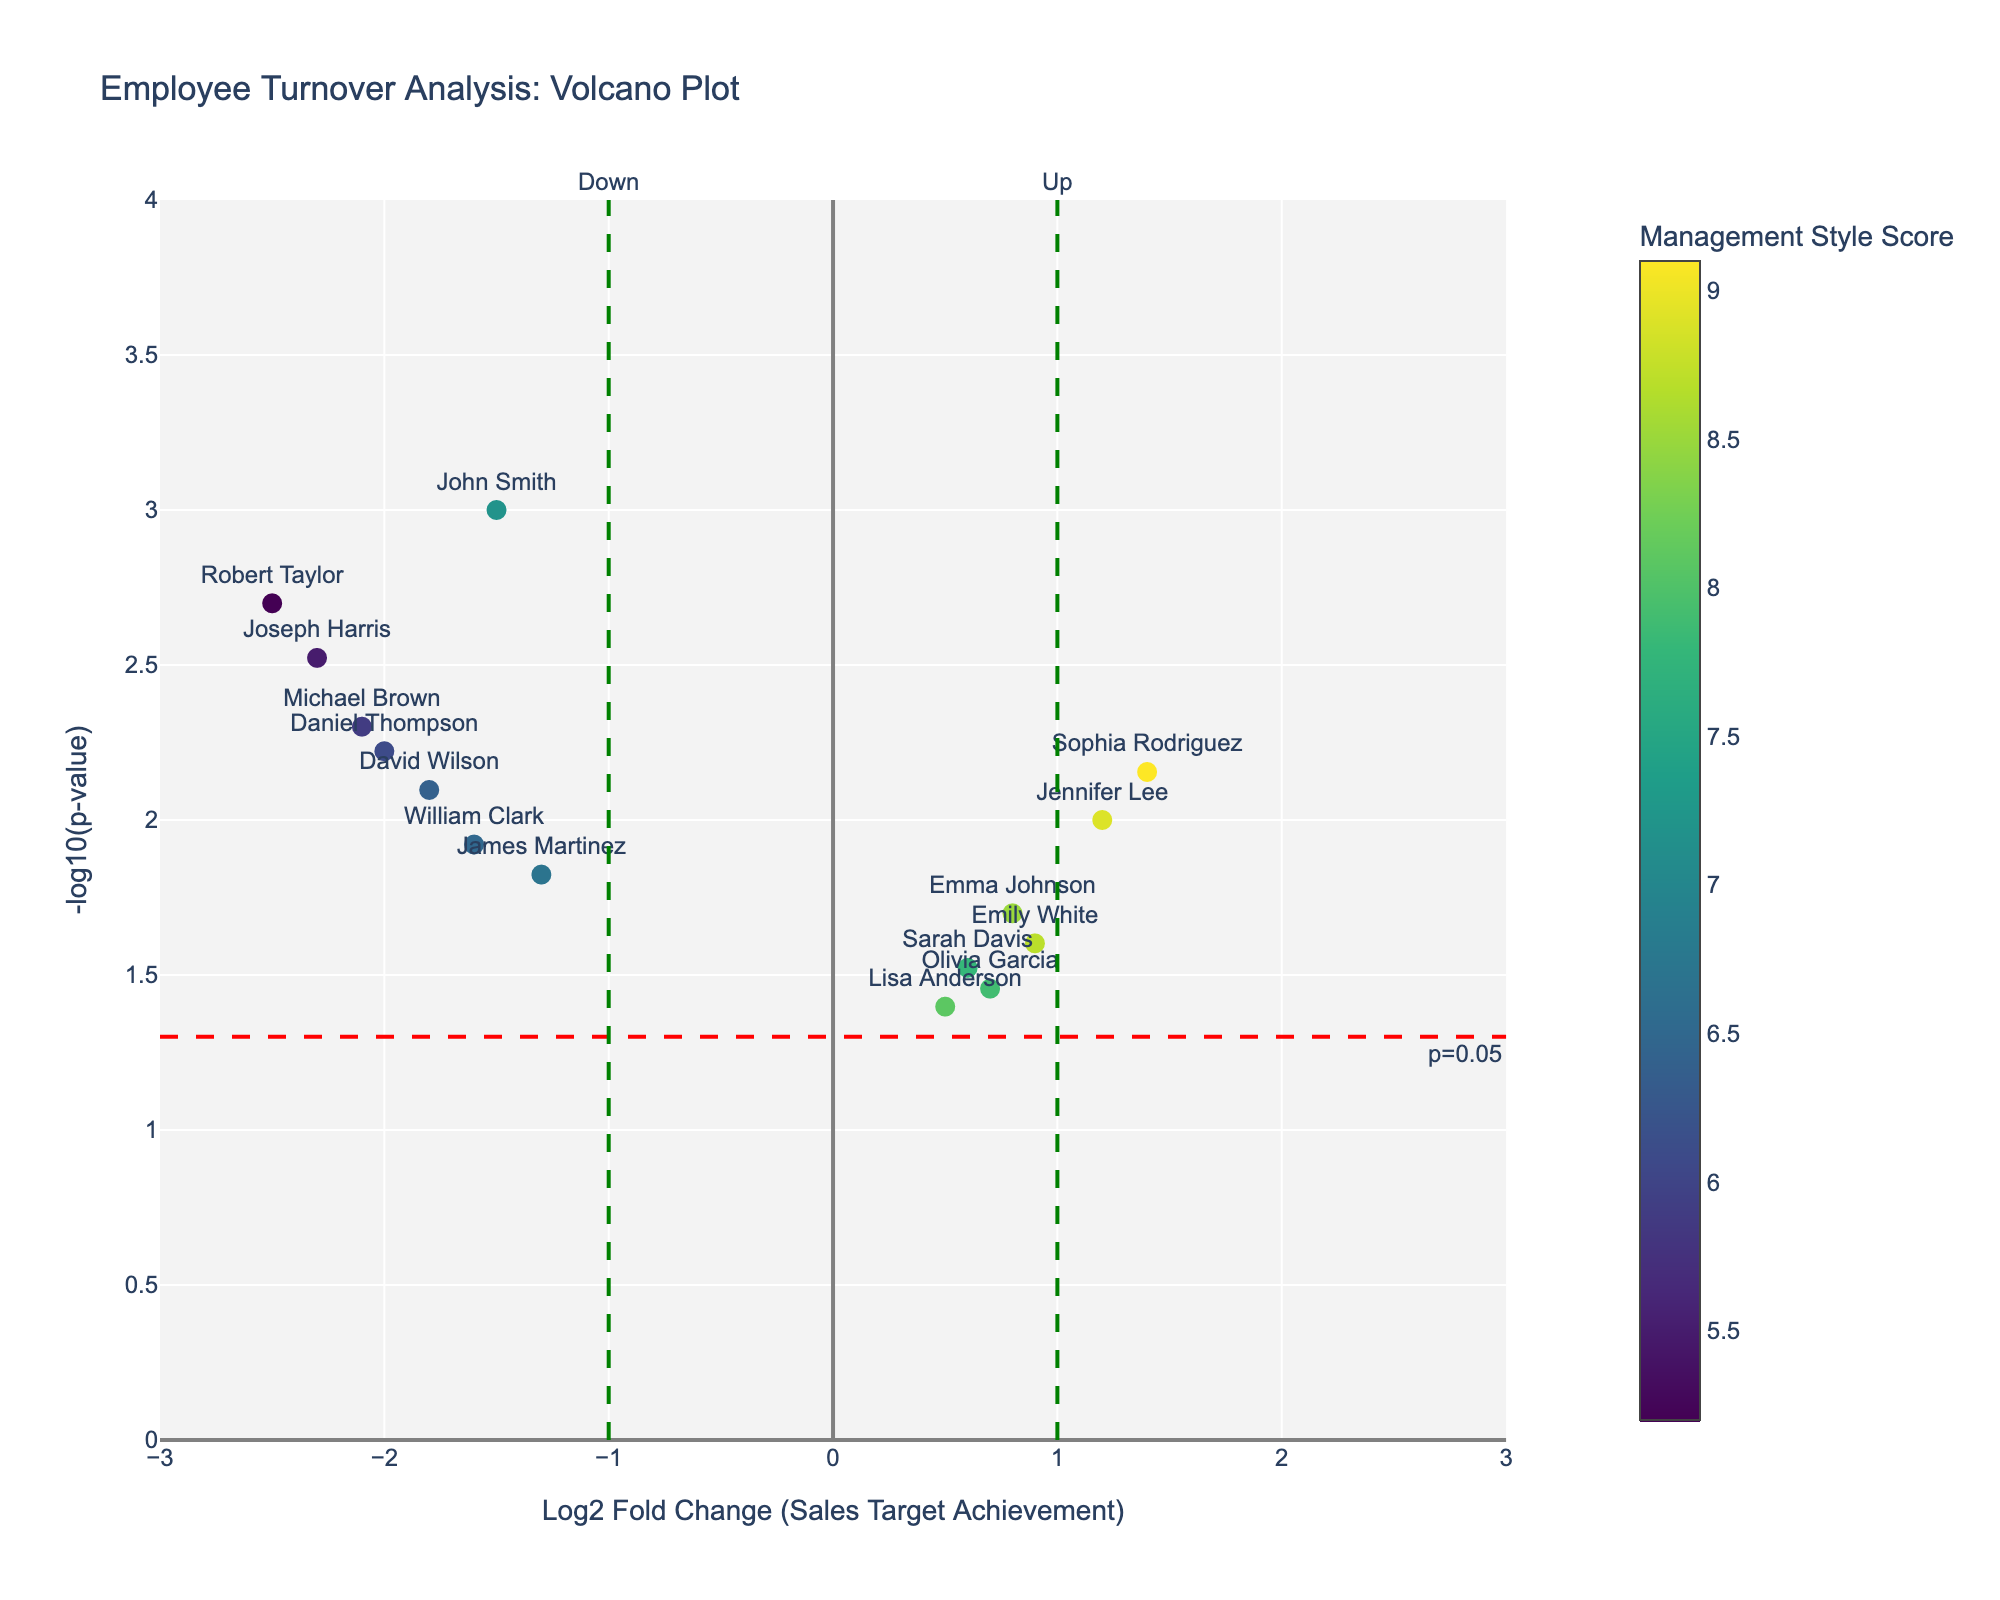Which employee has the highest management style score? The color bar shows the management style scores of the employees, with a Viridis color scale. By examining the darkest colored point, Sophia Rodriguez has the highest score (9.1).
Answer: Sophia Rodriguez What’s the significance threshold in the plot? The plot includes a red horizontal dashed line labeled "p=0.05," which represents the significance threshold. This corresponds to a -log10(p-value) of 1.3.
Answer: 1.3 How many employees have a negative log2 fold change value? Look at the points left of the y-axis (log2 fold change < 0). These include John Smith, Michael Brown, David Wilson, Robert Taylor, James Martinez, William Clark, Daniel Thompson, and Joseph Harris. There are 8 employees in total.
Answer: 8 Which employee had the highest sales target achievement? Each data point includes the employee name. Jennifer Lee has the highest log2 fold change, indicating the highest sales target achievement (115).
Answer: Jennifer Lee What is the turnover rate for the employee with the lowest p-value? The employee with the lowest p-value is Robert Taylor (p=0.002). The turnover rate is indicated by the size of the marker, which is 0.25.
Answer: 0.25 How many employees are considered statistically significant (p-value < 0.05)? Points above the red horizontal dashed line (-log10(p-value) = 1.3) are statistically significant. There are 7 such points.
Answer: 7 Which employee has the lowest log2 fold change? The data point furthest to the left on the x-axis represents the lowest log2 fold change. Robert Taylor has the lowest log2 fold change (-2.5).
Answer: Robert Taylor Compare the turnover rates of employees with a log2 fold change of greater than 1 and less than -1. The employees with a log2 fold change > 1 are Jennifer Lee and Sophia Rodriguez (0.06 and 0.05 turnover rates, respectively). The employees with log2 fold change < -1 are John Smith, Michael Brown, David Wilson, Robert Taylor, James Martinez, William Clark, Daniel Thompson, and Joseph Harris (turnover rates ranging from 0.15 to 0.25). The average for those > 1 is 0.055, while the average for those < -1 is around 0.2.
Answer: Less than 1 What is the average log2 fold change for all employees? Sum all log2 fold change values and divide by the total number of employees: (-1.5 + 0.8 - 2.1 + 0.6 - 1.8 + 1.2 -2.5 + 0.5 - 1.3 + 0.9 - 2.0 + 0.7 - 1.6 + 1.4 - 2.3) / 15, which equals -0.867 / 15 = -0.0578.
Answer: -0.0578 